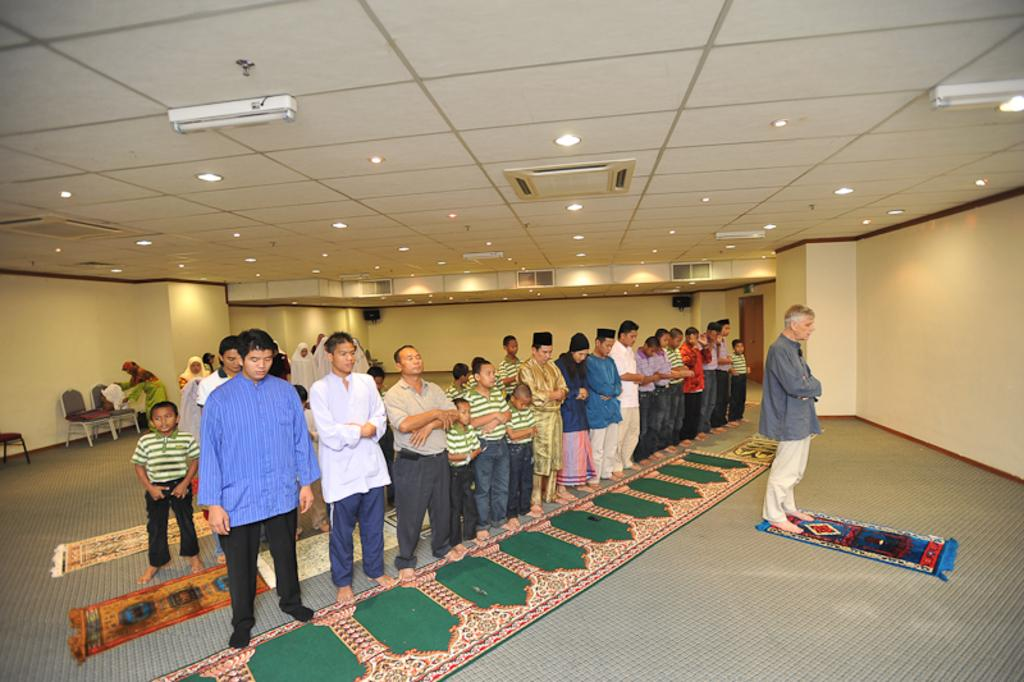What are the people in the image doing? The people in the image are offering namaz. What can be seen in the background of the image? There is a wall in the background of the image. Are there any additional features visible on the roof in the image? Yes, lights are attached to the roof in the image. What type of haircut is the person in the image getting? There is no haircut being performed in the image; the people are offering namaz. How does the brain of the person in the image look while they are praying? There is no visible representation of the brain in the image; it focuses on the people offering namaz and the surrounding environment. 